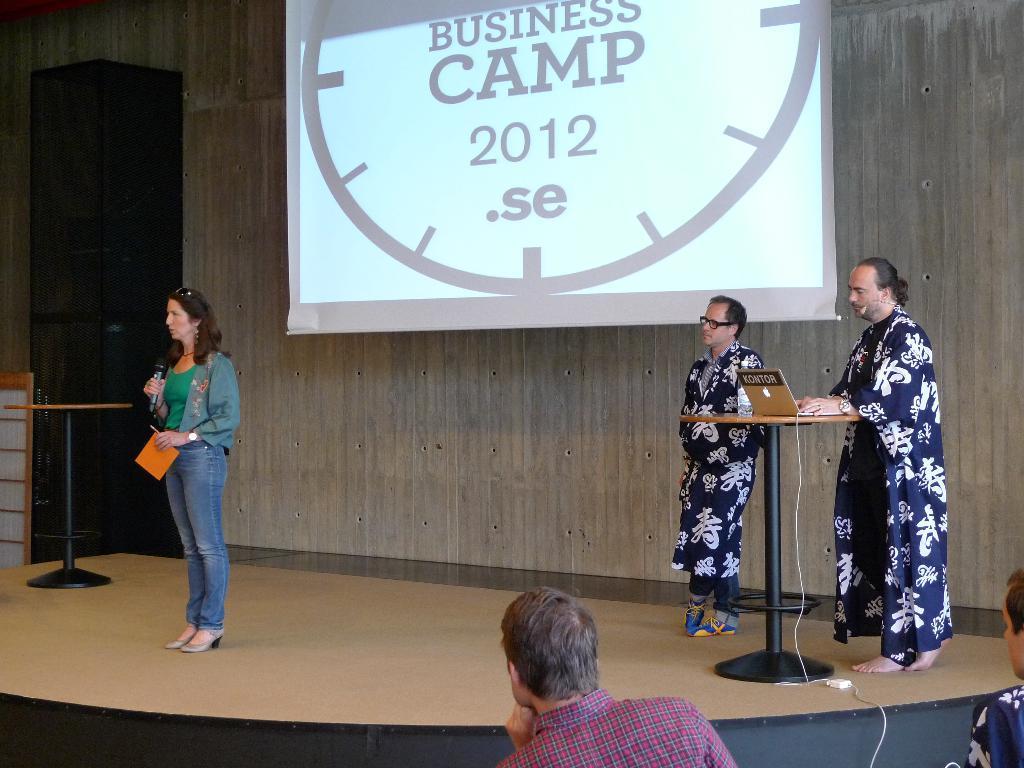In one or two sentences, can you explain what this image depicts? In the picture I can see a woman wearing green color dress, jeans is holding a mic and some paper in her hands and standing on the stage and here we can see these two persons wearing black color dresses are standing near the table where the laptop is placed on it, we can see the projector screen on which something is displayed, here I can see a black object on the right side of the image and here I can see a person sitting in front of the image. 